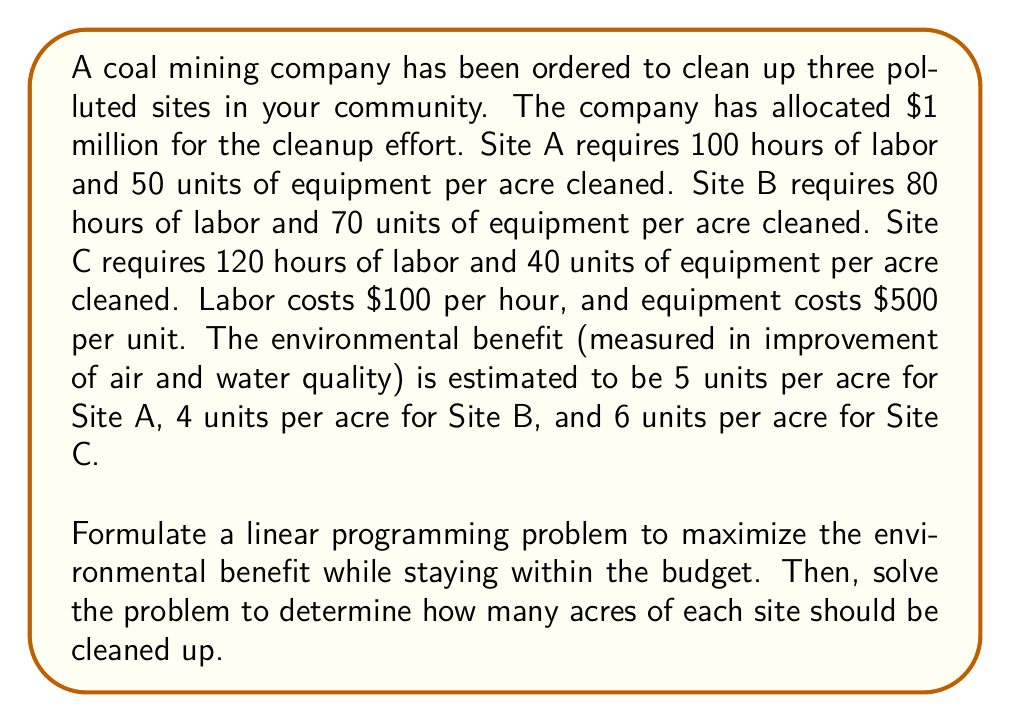Teach me how to tackle this problem. Let's approach this problem step by step:

1) Define variables:
   Let $x_A$, $x_B$, and $x_C$ be the number of acres cleaned up at Sites A, B, and C respectively.

2) Formulate the objective function:
   We want to maximize the environmental benefit:
   $$\text{Maximize } Z = 5x_A + 4x_B + 6x_C$$

3) Formulate the constraints:
   a) Budget constraint:
      Cost of labor + Cost of equipment ≤ $1 million
      $$(100 \cdot 100 + 50 \cdot 500)x_A + (80 \cdot 100 + 70 \cdot 500)x_B + (120 \cdot 100 + 40 \cdot 500)x_C \leq 1,000,000$$
      Simplifying:
      $$35,000x_A + 43,000x_B + 32,000x_C \leq 1,000,000$$

   b) Non-negativity constraints:
      $$x_A \geq 0, x_B \geq 0, x_C \geq 0$$

4) Solve the linear programming problem:
   We can solve this using the simplex method or a linear programming solver. Using a solver, we get:

   $x_A = 0$
   $x_B = 0$
   $x_C = 31.25$

5) Interpret the results:
   The optimal solution is to clean up 31.25 acres of Site C, which will provide a total environmental benefit of 187.5 units (6 * 31.25).
Answer: The optimal allocation is to clean up 31.25 acres of Site C, resulting in a maximum environmental benefit of 187.5 units. 